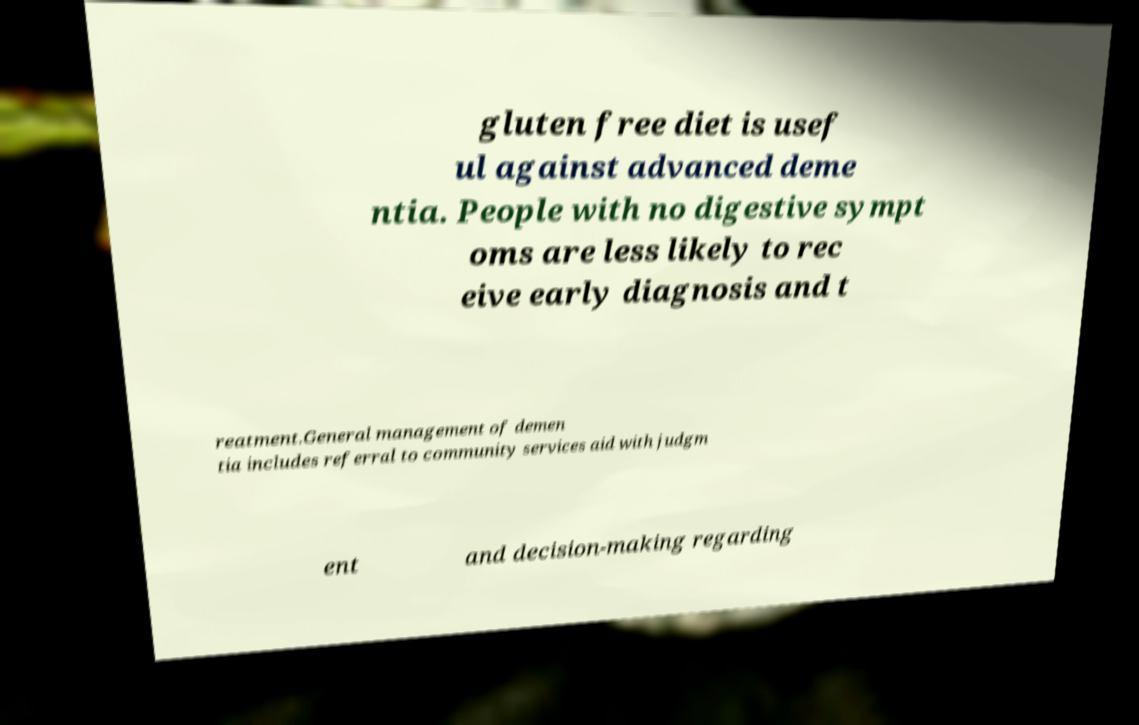Please identify and transcribe the text found in this image. gluten free diet is usef ul against advanced deme ntia. People with no digestive sympt oms are less likely to rec eive early diagnosis and t reatment.General management of demen tia includes referral to community services aid with judgm ent and decision-making regarding 